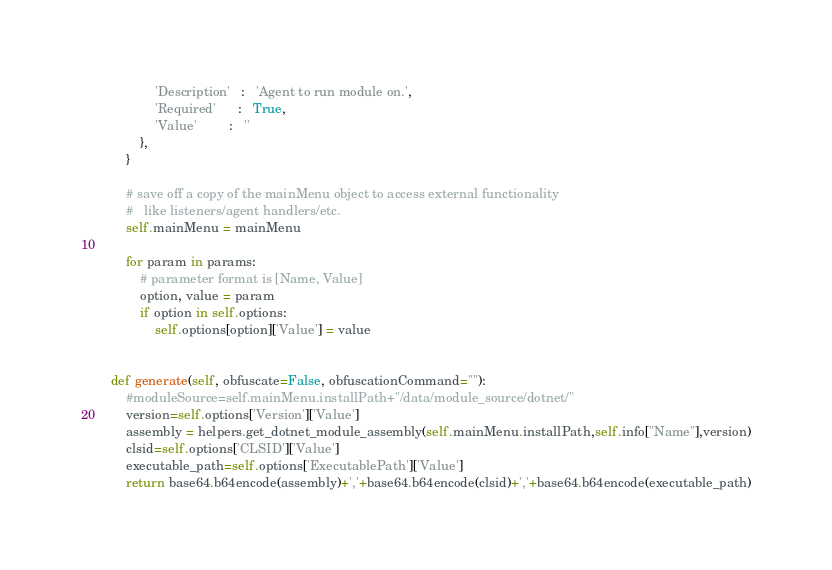<code> <loc_0><loc_0><loc_500><loc_500><_Python_>                'Description'   :   'Agent to run module on.',
                'Required'      :   True,
                'Value'         :   ''
            },
        }

        # save off a copy of the mainMenu object to access external functionality
        #   like listeners/agent handlers/etc.
        self.mainMenu = mainMenu

        for param in params:
            # parameter format is [Name, Value]
            option, value = param
            if option in self.options:
                self.options[option]['Value'] = value


    def generate(self, obfuscate=False, obfuscationCommand=""):
        #moduleSource=self.mainMenu.installPath+"/data/module_source/dotnet/"
        version=self.options['Version']['Value']
        assembly = helpers.get_dotnet_module_assembly(self.mainMenu.installPath,self.info["Name"],version)
        clsid=self.options['CLSID']['Value']
        executable_path=self.options['ExecutablePath']['Value']
        return base64.b64encode(assembly)+','+base64.b64encode(clsid)+','+base64.b64encode(executable_path)
</code> 